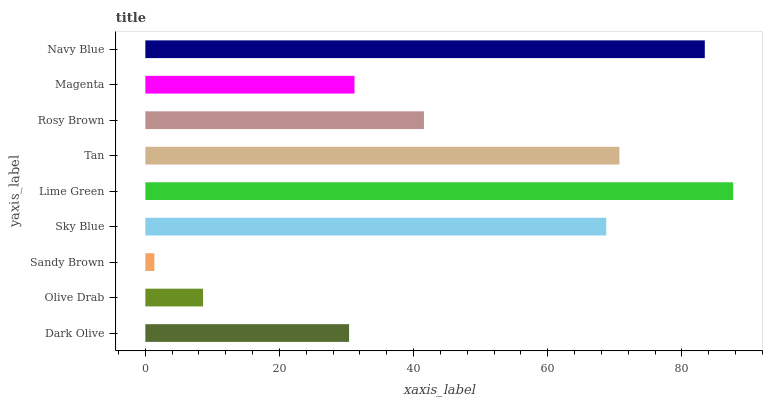Is Sandy Brown the minimum?
Answer yes or no. Yes. Is Lime Green the maximum?
Answer yes or no. Yes. Is Olive Drab the minimum?
Answer yes or no. No. Is Olive Drab the maximum?
Answer yes or no. No. Is Dark Olive greater than Olive Drab?
Answer yes or no. Yes. Is Olive Drab less than Dark Olive?
Answer yes or no. Yes. Is Olive Drab greater than Dark Olive?
Answer yes or no. No. Is Dark Olive less than Olive Drab?
Answer yes or no. No. Is Rosy Brown the high median?
Answer yes or no. Yes. Is Rosy Brown the low median?
Answer yes or no. Yes. Is Magenta the high median?
Answer yes or no. No. Is Magenta the low median?
Answer yes or no. No. 